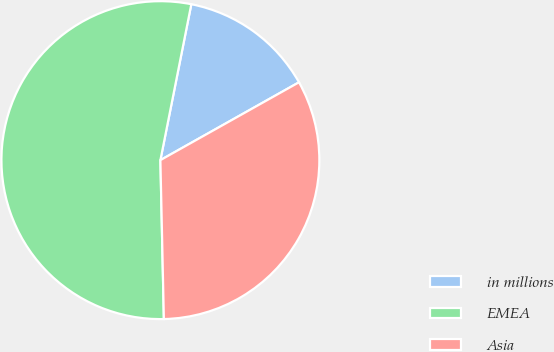Convert chart. <chart><loc_0><loc_0><loc_500><loc_500><pie_chart><fcel>in millions<fcel>EMEA<fcel>Asia<nl><fcel>13.74%<fcel>53.47%<fcel>32.8%<nl></chart> 